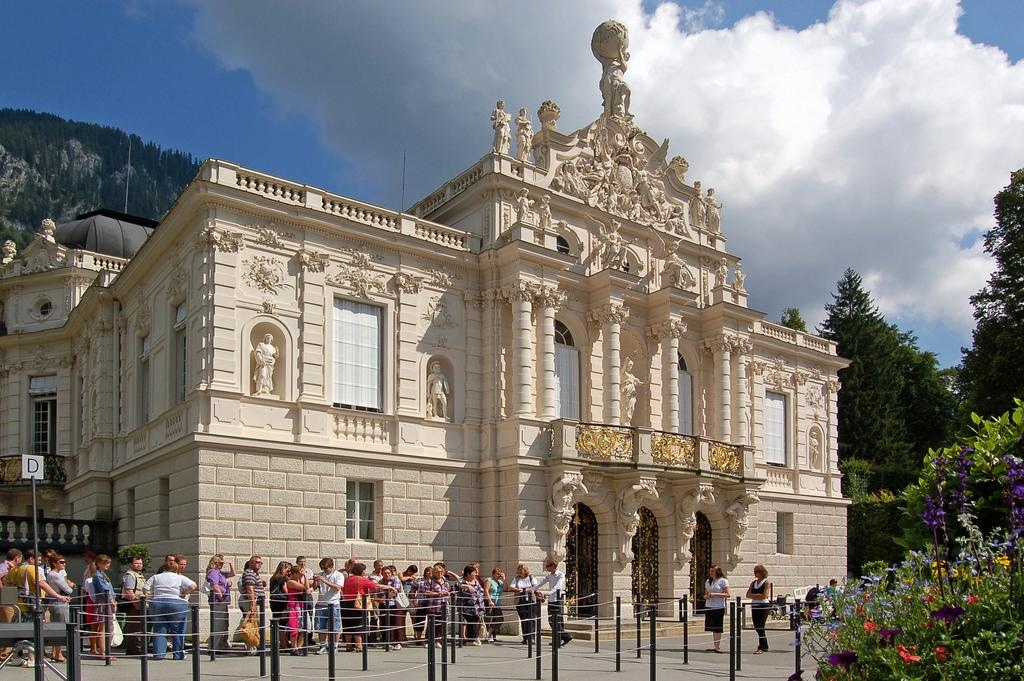What type of structure is present in the image? There is a building in the image. What features can be seen on the building? The building has sculptures and windows. What other objects are visible in the image? There are poles and trees in the image. What can be seen in the background of the image? The sky is visible in the background of the image. Can you hear the rhythm of the building in the image? There is no audible rhythm associated with the building in the image; it is a visual representation. 